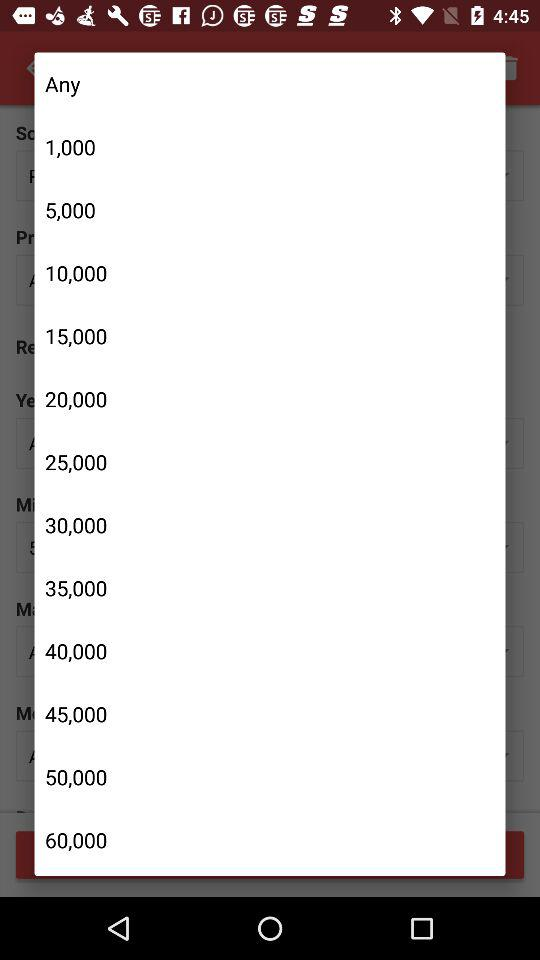How much more is the price of 50,000 than 10,000?
Answer the question using a single word or phrase. 40,000 